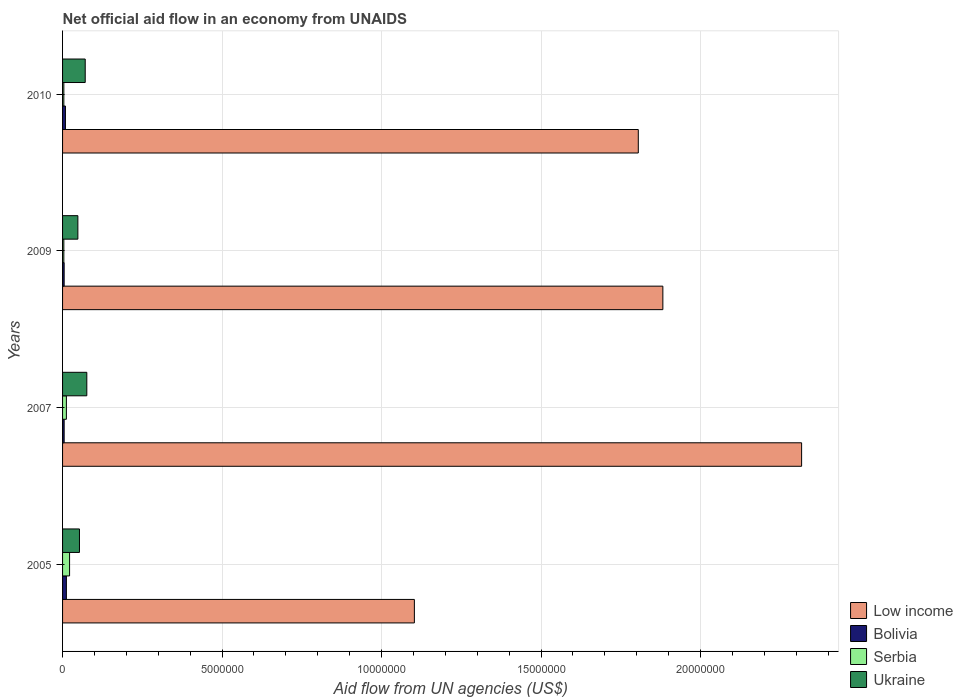In how many cases, is the number of bars for a given year not equal to the number of legend labels?
Make the answer very short. 0. What is the net official aid flow in Low income in 2010?
Offer a terse response. 1.80e+07. Across all years, what is the maximum net official aid flow in Ukraine?
Keep it short and to the point. 7.60e+05. What is the total net official aid flow in Low income in the graph?
Provide a succinct answer. 7.11e+07. What is the difference between the net official aid flow in Low income in 2005 and that in 2010?
Provide a short and direct response. -7.02e+06. What is the difference between the net official aid flow in Ukraine in 2009 and the net official aid flow in Bolivia in 2007?
Ensure brevity in your answer.  4.30e+05. What is the average net official aid flow in Ukraine per year?
Ensure brevity in your answer.  6.20e+05. In the year 2005, what is the difference between the net official aid flow in Low income and net official aid flow in Bolivia?
Ensure brevity in your answer.  1.09e+07. What is the ratio of the net official aid flow in Bolivia in 2007 to that in 2010?
Offer a terse response. 0.56. Is the difference between the net official aid flow in Low income in 2007 and 2009 greater than the difference between the net official aid flow in Bolivia in 2007 and 2009?
Your answer should be compact. Yes. What is the difference between the highest and the lowest net official aid flow in Low income?
Offer a very short reply. 1.21e+07. In how many years, is the net official aid flow in Ukraine greater than the average net official aid flow in Ukraine taken over all years?
Your response must be concise. 2. Is it the case that in every year, the sum of the net official aid flow in Low income and net official aid flow in Bolivia is greater than the sum of net official aid flow in Serbia and net official aid flow in Ukraine?
Your response must be concise. Yes. What does the 2nd bar from the top in 2010 represents?
Your answer should be compact. Serbia. What does the 4th bar from the bottom in 2005 represents?
Offer a very short reply. Ukraine. How many years are there in the graph?
Make the answer very short. 4. Are the values on the major ticks of X-axis written in scientific E-notation?
Make the answer very short. No. Does the graph contain any zero values?
Ensure brevity in your answer.  No. Does the graph contain grids?
Your answer should be very brief. Yes. Where does the legend appear in the graph?
Provide a succinct answer. Bottom right. How many legend labels are there?
Offer a terse response. 4. How are the legend labels stacked?
Your response must be concise. Vertical. What is the title of the graph?
Give a very brief answer. Net official aid flow in an economy from UNAIDS. Does "Comoros" appear as one of the legend labels in the graph?
Make the answer very short. No. What is the label or title of the X-axis?
Offer a terse response. Aid flow from UN agencies (US$). What is the label or title of the Y-axis?
Ensure brevity in your answer.  Years. What is the Aid flow from UN agencies (US$) of Low income in 2005?
Offer a very short reply. 1.10e+07. What is the Aid flow from UN agencies (US$) of Bolivia in 2005?
Give a very brief answer. 1.20e+05. What is the Aid flow from UN agencies (US$) in Ukraine in 2005?
Your response must be concise. 5.30e+05. What is the Aid flow from UN agencies (US$) in Low income in 2007?
Ensure brevity in your answer.  2.32e+07. What is the Aid flow from UN agencies (US$) in Bolivia in 2007?
Make the answer very short. 5.00e+04. What is the Aid flow from UN agencies (US$) in Ukraine in 2007?
Give a very brief answer. 7.60e+05. What is the Aid flow from UN agencies (US$) in Low income in 2009?
Keep it short and to the point. 1.88e+07. What is the Aid flow from UN agencies (US$) of Low income in 2010?
Provide a succinct answer. 1.80e+07. What is the Aid flow from UN agencies (US$) of Serbia in 2010?
Your answer should be very brief. 4.00e+04. What is the Aid flow from UN agencies (US$) of Ukraine in 2010?
Give a very brief answer. 7.10e+05. Across all years, what is the maximum Aid flow from UN agencies (US$) in Low income?
Provide a short and direct response. 2.32e+07. Across all years, what is the maximum Aid flow from UN agencies (US$) in Bolivia?
Your response must be concise. 1.20e+05. Across all years, what is the maximum Aid flow from UN agencies (US$) in Serbia?
Keep it short and to the point. 2.20e+05. Across all years, what is the maximum Aid flow from UN agencies (US$) of Ukraine?
Provide a succinct answer. 7.60e+05. Across all years, what is the minimum Aid flow from UN agencies (US$) of Low income?
Offer a terse response. 1.10e+07. What is the total Aid flow from UN agencies (US$) of Low income in the graph?
Offer a very short reply. 7.11e+07. What is the total Aid flow from UN agencies (US$) of Ukraine in the graph?
Offer a very short reply. 2.48e+06. What is the difference between the Aid flow from UN agencies (US$) of Low income in 2005 and that in 2007?
Make the answer very short. -1.21e+07. What is the difference between the Aid flow from UN agencies (US$) in Ukraine in 2005 and that in 2007?
Provide a succinct answer. -2.30e+05. What is the difference between the Aid flow from UN agencies (US$) in Low income in 2005 and that in 2009?
Offer a very short reply. -7.79e+06. What is the difference between the Aid flow from UN agencies (US$) in Serbia in 2005 and that in 2009?
Your answer should be compact. 1.80e+05. What is the difference between the Aid flow from UN agencies (US$) in Low income in 2005 and that in 2010?
Provide a short and direct response. -7.02e+06. What is the difference between the Aid flow from UN agencies (US$) in Bolivia in 2005 and that in 2010?
Your answer should be very brief. 3.00e+04. What is the difference between the Aid flow from UN agencies (US$) of Ukraine in 2005 and that in 2010?
Your answer should be very brief. -1.80e+05. What is the difference between the Aid flow from UN agencies (US$) of Low income in 2007 and that in 2009?
Provide a short and direct response. 4.35e+06. What is the difference between the Aid flow from UN agencies (US$) in Serbia in 2007 and that in 2009?
Offer a very short reply. 8.00e+04. What is the difference between the Aid flow from UN agencies (US$) in Ukraine in 2007 and that in 2009?
Your answer should be very brief. 2.80e+05. What is the difference between the Aid flow from UN agencies (US$) of Low income in 2007 and that in 2010?
Make the answer very short. 5.12e+06. What is the difference between the Aid flow from UN agencies (US$) in Bolivia in 2007 and that in 2010?
Your response must be concise. -4.00e+04. What is the difference between the Aid flow from UN agencies (US$) in Low income in 2009 and that in 2010?
Offer a very short reply. 7.70e+05. What is the difference between the Aid flow from UN agencies (US$) of Low income in 2005 and the Aid flow from UN agencies (US$) of Bolivia in 2007?
Your answer should be compact. 1.10e+07. What is the difference between the Aid flow from UN agencies (US$) in Low income in 2005 and the Aid flow from UN agencies (US$) in Serbia in 2007?
Provide a short and direct response. 1.09e+07. What is the difference between the Aid flow from UN agencies (US$) in Low income in 2005 and the Aid flow from UN agencies (US$) in Ukraine in 2007?
Make the answer very short. 1.03e+07. What is the difference between the Aid flow from UN agencies (US$) in Bolivia in 2005 and the Aid flow from UN agencies (US$) in Serbia in 2007?
Ensure brevity in your answer.  0. What is the difference between the Aid flow from UN agencies (US$) in Bolivia in 2005 and the Aid flow from UN agencies (US$) in Ukraine in 2007?
Make the answer very short. -6.40e+05. What is the difference between the Aid flow from UN agencies (US$) of Serbia in 2005 and the Aid flow from UN agencies (US$) of Ukraine in 2007?
Keep it short and to the point. -5.40e+05. What is the difference between the Aid flow from UN agencies (US$) of Low income in 2005 and the Aid flow from UN agencies (US$) of Bolivia in 2009?
Your answer should be compact. 1.10e+07. What is the difference between the Aid flow from UN agencies (US$) in Low income in 2005 and the Aid flow from UN agencies (US$) in Serbia in 2009?
Make the answer very short. 1.10e+07. What is the difference between the Aid flow from UN agencies (US$) of Low income in 2005 and the Aid flow from UN agencies (US$) of Ukraine in 2009?
Offer a very short reply. 1.06e+07. What is the difference between the Aid flow from UN agencies (US$) of Bolivia in 2005 and the Aid flow from UN agencies (US$) of Ukraine in 2009?
Offer a very short reply. -3.60e+05. What is the difference between the Aid flow from UN agencies (US$) in Serbia in 2005 and the Aid flow from UN agencies (US$) in Ukraine in 2009?
Provide a short and direct response. -2.60e+05. What is the difference between the Aid flow from UN agencies (US$) in Low income in 2005 and the Aid flow from UN agencies (US$) in Bolivia in 2010?
Your answer should be compact. 1.09e+07. What is the difference between the Aid flow from UN agencies (US$) in Low income in 2005 and the Aid flow from UN agencies (US$) in Serbia in 2010?
Keep it short and to the point. 1.10e+07. What is the difference between the Aid flow from UN agencies (US$) in Low income in 2005 and the Aid flow from UN agencies (US$) in Ukraine in 2010?
Provide a short and direct response. 1.03e+07. What is the difference between the Aid flow from UN agencies (US$) of Bolivia in 2005 and the Aid flow from UN agencies (US$) of Serbia in 2010?
Offer a terse response. 8.00e+04. What is the difference between the Aid flow from UN agencies (US$) in Bolivia in 2005 and the Aid flow from UN agencies (US$) in Ukraine in 2010?
Offer a very short reply. -5.90e+05. What is the difference between the Aid flow from UN agencies (US$) of Serbia in 2005 and the Aid flow from UN agencies (US$) of Ukraine in 2010?
Your answer should be compact. -4.90e+05. What is the difference between the Aid flow from UN agencies (US$) of Low income in 2007 and the Aid flow from UN agencies (US$) of Bolivia in 2009?
Your answer should be compact. 2.31e+07. What is the difference between the Aid flow from UN agencies (US$) in Low income in 2007 and the Aid flow from UN agencies (US$) in Serbia in 2009?
Your response must be concise. 2.31e+07. What is the difference between the Aid flow from UN agencies (US$) of Low income in 2007 and the Aid flow from UN agencies (US$) of Ukraine in 2009?
Keep it short and to the point. 2.27e+07. What is the difference between the Aid flow from UN agencies (US$) in Bolivia in 2007 and the Aid flow from UN agencies (US$) in Ukraine in 2009?
Offer a terse response. -4.30e+05. What is the difference between the Aid flow from UN agencies (US$) of Serbia in 2007 and the Aid flow from UN agencies (US$) of Ukraine in 2009?
Offer a very short reply. -3.60e+05. What is the difference between the Aid flow from UN agencies (US$) in Low income in 2007 and the Aid flow from UN agencies (US$) in Bolivia in 2010?
Your answer should be very brief. 2.31e+07. What is the difference between the Aid flow from UN agencies (US$) in Low income in 2007 and the Aid flow from UN agencies (US$) in Serbia in 2010?
Make the answer very short. 2.31e+07. What is the difference between the Aid flow from UN agencies (US$) in Low income in 2007 and the Aid flow from UN agencies (US$) in Ukraine in 2010?
Give a very brief answer. 2.25e+07. What is the difference between the Aid flow from UN agencies (US$) in Bolivia in 2007 and the Aid flow from UN agencies (US$) in Serbia in 2010?
Give a very brief answer. 10000. What is the difference between the Aid flow from UN agencies (US$) of Bolivia in 2007 and the Aid flow from UN agencies (US$) of Ukraine in 2010?
Ensure brevity in your answer.  -6.60e+05. What is the difference between the Aid flow from UN agencies (US$) in Serbia in 2007 and the Aid flow from UN agencies (US$) in Ukraine in 2010?
Your response must be concise. -5.90e+05. What is the difference between the Aid flow from UN agencies (US$) in Low income in 2009 and the Aid flow from UN agencies (US$) in Bolivia in 2010?
Provide a succinct answer. 1.87e+07. What is the difference between the Aid flow from UN agencies (US$) in Low income in 2009 and the Aid flow from UN agencies (US$) in Serbia in 2010?
Offer a terse response. 1.88e+07. What is the difference between the Aid flow from UN agencies (US$) in Low income in 2009 and the Aid flow from UN agencies (US$) in Ukraine in 2010?
Keep it short and to the point. 1.81e+07. What is the difference between the Aid flow from UN agencies (US$) in Bolivia in 2009 and the Aid flow from UN agencies (US$) in Ukraine in 2010?
Your response must be concise. -6.60e+05. What is the difference between the Aid flow from UN agencies (US$) in Serbia in 2009 and the Aid flow from UN agencies (US$) in Ukraine in 2010?
Give a very brief answer. -6.70e+05. What is the average Aid flow from UN agencies (US$) of Low income per year?
Offer a very short reply. 1.78e+07. What is the average Aid flow from UN agencies (US$) in Bolivia per year?
Offer a very short reply. 7.75e+04. What is the average Aid flow from UN agencies (US$) of Serbia per year?
Make the answer very short. 1.05e+05. What is the average Aid flow from UN agencies (US$) of Ukraine per year?
Make the answer very short. 6.20e+05. In the year 2005, what is the difference between the Aid flow from UN agencies (US$) in Low income and Aid flow from UN agencies (US$) in Bolivia?
Offer a terse response. 1.09e+07. In the year 2005, what is the difference between the Aid flow from UN agencies (US$) of Low income and Aid flow from UN agencies (US$) of Serbia?
Give a very brief answer. 1.08e+07. In the year 2005, what is the difference between the Aid flow from UN agencies (US$) in Low income and Aid flow from UN agencies (US$) in Ukraine?
Your answer should be very brief. 1.05e+07. In the year 2005, what is the difference between the Aid flow from UN agencies (US$) in Bolivia and Aid flow from UN agencies (US$) in Serbia?
Offer a very short reply. -1.00e+05. In the year 2005, what is the difference between the Aid flow from UN agencies (US$) in Bolivia and Aid flow from UN agencies (US$) in Ukraine?
Offer a terse response. -4.10e+05. In the year 2005, what is the difference between the Aid flow from UN agencies (US$) of Serbia and Aid flow from UN agencies (US$) of Ukraine?
Your response must be concise. -3.10e+05. In the year 2007, what is the difference between the Aid flow from UN agencies (US$) of Low income and Aid flow from UN agencies (US$) of Bolivia?
Keep it short and to the point. 2.31e+07. In the year 2007, what is the difference between the Aid flow from UN agencies (US$) in Low income and Aid flow from UN agencies (US$) in Serbia?
Provide a succinct answer. 2.30e+07. In the year 2007, what is the difference between the Aid flow from UN agencies (US$) in Low income and Aid flow from UN agencies (US$) in Ukraine?
Your answer should be very brief. 2.24e+07. In the year 2007, what is the difference between the Aid flow from UN agencies (US$) of Bolivia and Aid flow from UN agencies (US$) of Serbia?
Offer a very short reply. -7.00e+04. In the year 2007, what is the difference between the Aid flow from UN agencies (US$) in Bolivia and Aid flow from UN agencies (US$) in Ukraine?
Your answer should be very brief. -7.10e+05. In the year 2007, what is the difference between the Aid flow from UN agencies (US$) in Serbia and Aid flow from UN agencies (US$) in Ukraine?
Give a very brief answer. -6.40e+05. In the year 2009, what is the difference between the Aid flow from UN agencies (US$) of Low income and Aid flow from UN agencies (US$) of Bolivia?
Offer a terse response. 1.88e+07. In the year 2009, what is the difference between the Aid flow from UN agencies (US$) in Low income and Aid flow from UN agencies (US$) in Serbia?
Your answer should be very brief. 1.88e+07. In the year 2009, what is the difference between the Aid flow from UN agencies (US$) of Low income and Aid flow from UN agencies (US$) of Ukraine?
Provide a succinct answer. 1.83e+07. In the year 2009, what is the difference between the Aid flow from UN agencies (US$) in Bolivia and Aid flow from UN agencies (US$) in Serbia?
Provide a short and direct response. 10000. In the year 2009, what is the difference between the Aid flow from UN agencies (US$) of Bolivia and Aid flow from UN agencies (US$) of Ukraine?
Make the answer very short. -4.30e+05. In the year 2009, what is the difference between the Aid flow from UN agencies (US$) in Serbia and Aid flow from UN agencies (US$) in Ukraine?
Offer a very short reply. -4.40e+05. In the year 2010, what is the difference between the Aid flow from UN agencies (US$) in Low income and Aid flow from UN agencies (US$) in Bolivia?
Keep it short and to the point. 1.80e+07. In the year 2010, what is the difference between the Aid flow from UN agencies (US$) in Low income and Aid flow from UN agencies (US$) in Serbia?
Keep it short and to the point. 1.80e+07. In the year 2010, what is the difference between the Aid flow from UN agencies (US$) in Low income and Aid flow from UN agencies (US$) in Ukraine?
Your response must be concise. 1.73e+07. In the year 2010, what is the difference between the Aid flow from UN agencies (US$) in Bolivia and Aid flow from UN agencies (US$) in Ukraine?
Give a very brief answer. -6.20e+05. In the year 2010, what is the difference between the Aid flow from UN agencies (US$) of Serbia and Aid flow from UN agencies (US$) of Ukraine?
Your response must be concise. -6.70e+05. What is the ratio of the Aid flow from UN agencies (US$) of Low income in 2005 to that in 2007?
Provide a succinct answer. 0.48. What is the ratio of the Aid flow from UN agencies (US$) of Bolivia in 2005 to that in 2007?
Offer a very short reply. 2.4. What is the ratio of the Aid flow from UN agencies (US$) of Serbia in 2005 to that in 2007?
Provide a short and direct response. 1.83. What is the ratio of the Aid flow from UN agencies (US$) of Ukraine in 2005 to that in 2007?
Offer a terse response. 0.7. What is the ratio of the Aid flow from UN agencies (US$) of Low income in 2005 to that in 2009?
Your response must be concise. 0.59. What is the ratio of the Aid flow from UN agencies (US$) of Bolivia in 2005 to that in 2009?
Your answer should be very brief. 2.4. What is the ratio of the Aid flow from UN agencies (US$) of Serbia in 2005 to that in 2009?
Offer a very short reply. 5.5. What is the ratio of the Aid flow from UN agencies (US$) in Ukraine in 2005 to that in 2009?
Offer a very short reply. 1.1. What is the ratio of the Aid flow from UN agencies (US$) in Low income in 2005 to that in 2010?
Your response must be concise. 0.61. What is the ratio of the Aid flow from UN agencies (US$) of Ukraine in 2005 to that in 2010?
Your answer should be compact. 0.75. What is the ratio of the Aid flow from UN agencies (US$) in Low income in 2007 to that in 2009?
Keep it short and to the point. 1.23. What is the ratio of the Aid flow from UN agencies (US$) of Bolivia in 2007 to that in 2009?
Offer a terse response. 1. What is the ratio of the Aid flow from UN agencies (US$) in Serbia in 2007 to that in 2009?
Keep it short and to the point. 3. What is the ratio of the Aid flow from UN agencies (US$) of Ukraine in 2007 to that in 2009?
Make the answer very short. 1.58. What is the ratio of the Aid flow from UN agencies (US$) in Low income in 2007 to that in 2010?
Offer a very short reply. 1.28. What is the ratio of the Aid flow from UN agencies (US$) in Bolivia in 2007 to that in 2010?
Keep it short and to the point. 0.56. What is the ratio of the Aid flow from UN agencies (US$) in Ukraine in 2007 to that in 2010?
Give a very brief answer. 1.07. What is the ratio of the Aid flow from UN agencies (US$) in Low income in 2009 to that in 2010?
Your answer should be very brief. 1.04. What is the ratio of the Aid flow from UN agencies (US$) of Bolivia in 2009 to that in 2010?
Keep it short and to the point. 0.56. What is the ratio of the Aid flow from UN agencies (US$) of Serbia in 2009 to that in 2010?
Your answer should be compact. 1. What is the ratio of the Aid flow from UN agencies (US$) of Ukraine in 2009 to that in 2010?
Your answer should be very brief. 0.68. What is the difference between the highest and the second highest Aid flow from UN agencies (US$) in Low income?
Ensure brevity in your answer.  4.35e+06. What is the difference between the highest and the second highest Aid flow from UN agencies (US$) of Bolivia?
Provide a short and direct response. 3.00e+04. What is the difference between the highest and the lowest Aid flow from UN agencies (US$) of Low income?
Give a very brief answer. 1.21e+07. What is the difference between the highest and the lowest Aid flow from UN agencies (US$) in Serbia?
Offer a very short reply. 1.80e+05. 